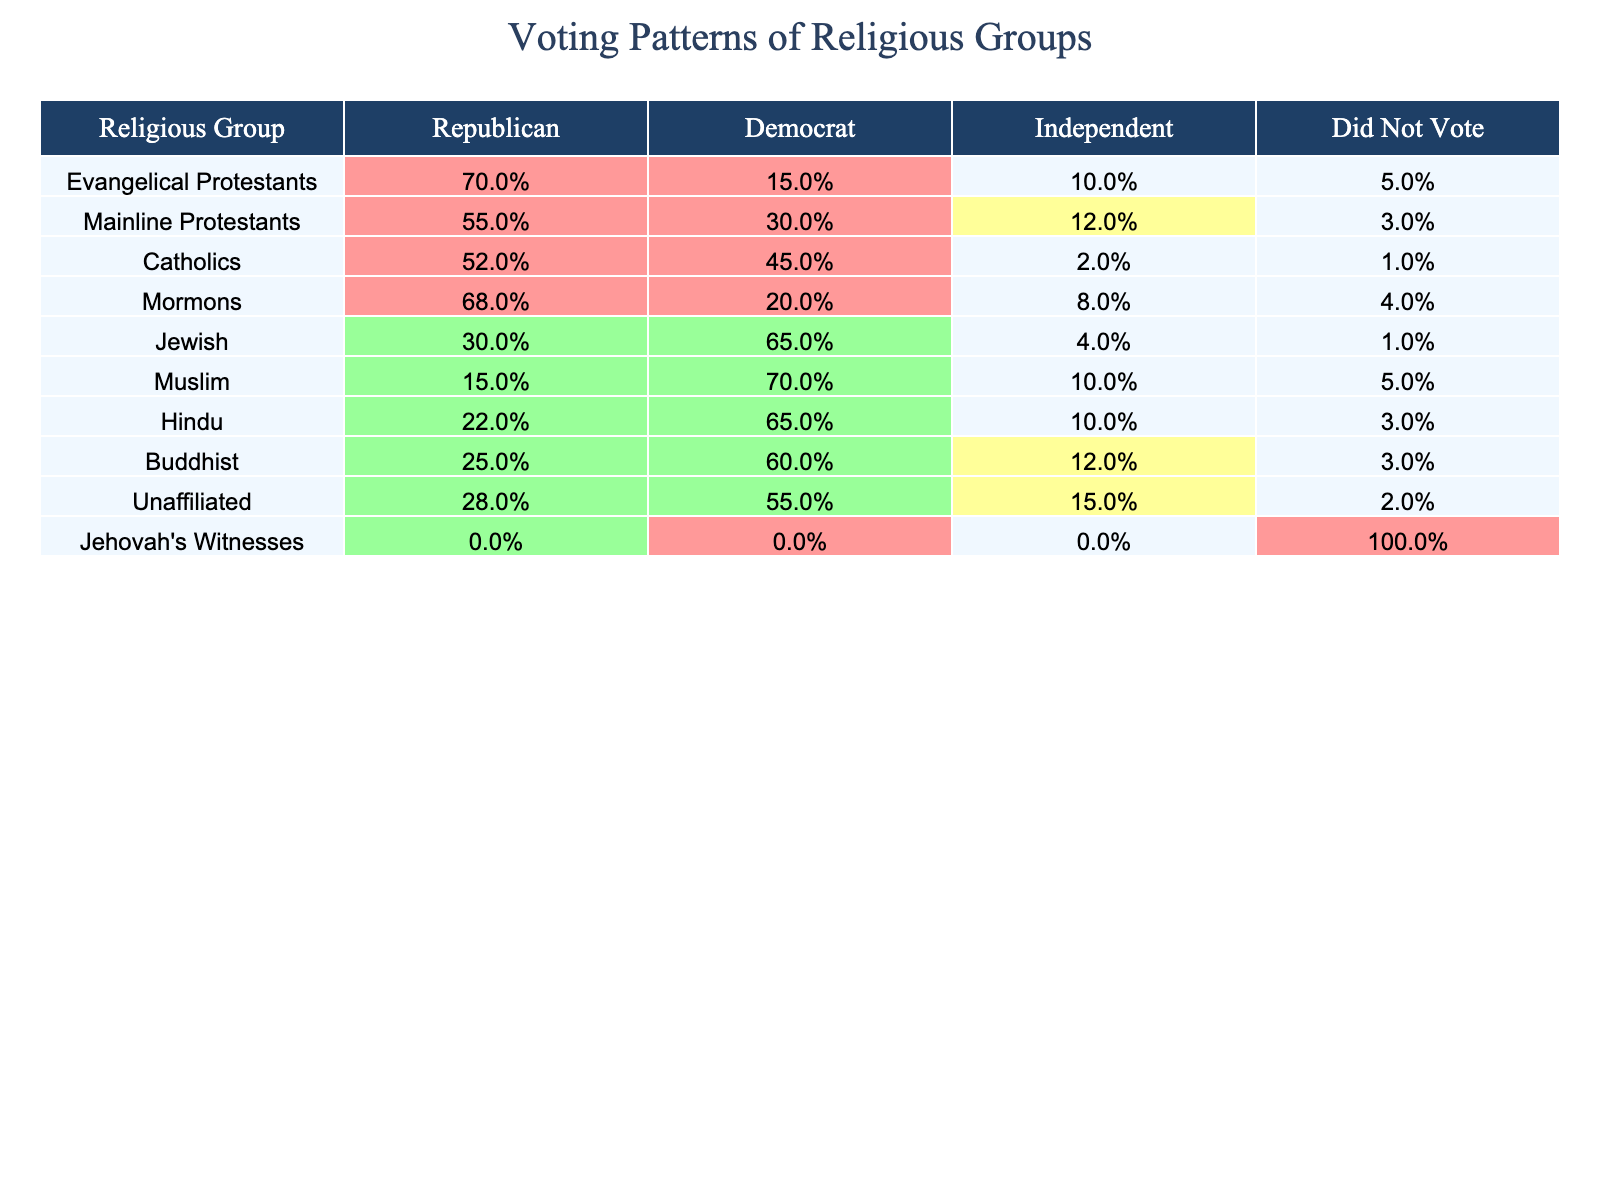What percentage of Evangelical Protestants voted for the Republican Party? Referring to the table, Evangelical Protestants show 70% voting for the Republican Party.
Answer: 70% Which religious group had the highest percentage of voters for the Democratic Party? The table indicates that Jewish individuals had the highest percentage, with 65% voting for the Democratic Party.
Answer: Jewish What is the percentage difference between Catholics who voted for Republican and Democratic parties? Catholics voted 52% for Republican and 45% for Democratic. The difference is 52% - 45% = 7%.
Answer: 7% Did any religious group have 100% of its members not voting? According to the table, Jehovah's Witnesses had 100% not voting.
Answer: Yes Which group had the lowest percentage of Independent voters? The group with the lowest Independent voters is Catholics, with only 2% voting as Independent.
Answer: Catholics What percentage of the Unaffiliated group did not vote? The Unaffiliated group had 2% of their members not voting, as noted in the table.
Answer: 2% What is the average percentage of Republican voters across all religious groups listed? Adding the percentages of Republican voters: 70 + 55 + 52 + 68 + 30 + 15 + 22 + 25 + 28 + 0 = 365, then dividing by 10 groups gives an average of 36.5%.
Answer: 36.5% How many religious groups voted less than 30% for the Republican Party? Referring to the table, Jewish (30%), Muslim (15%), and Jehovah's Witnesses (0%) voted less than 30%. That's 3 groups.
Answer: 3 What percentage of Mainline Protestants voted for the Republican Party compared to the average for all groups? Mainline Protestants voted 55% for Republican. The average for all groups is 36.5%. Comparing, 55% is higher than 36.5%.
Answer: Higher Which religious group has the highest percentage of "Did Not Vote"? Jehovah's Witnesses have 100% in the "Did Not Vote" category, which is the highest.
Answer: Jehovah's Witnesses What is the total percentage of voters (Republican, Democrat, Independent) for Mormons? Mormons voted 68% Republican, 20% Democrat, and 8% Independent. The total is 68% + 20% + 8% = 96%.
Answer: 96% 